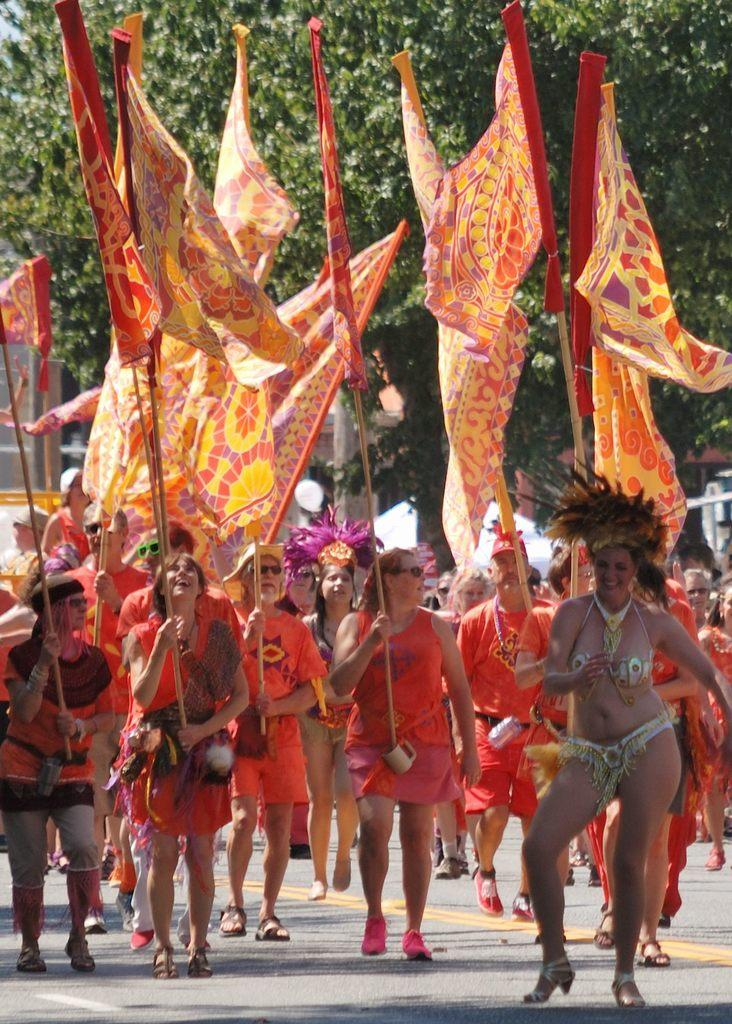What is happening on the road in the image? There are people on the road in the image. What are some of the people holding? Some of the people are holding flags. What objects can be seen in addition to the people and flags? There are mugs visible in the image. What type of natural element is present in the image? There is a tree in the image. What type of work is the porter doing in the image? There is no porter present in the image, so it is not possible to answer that question. 